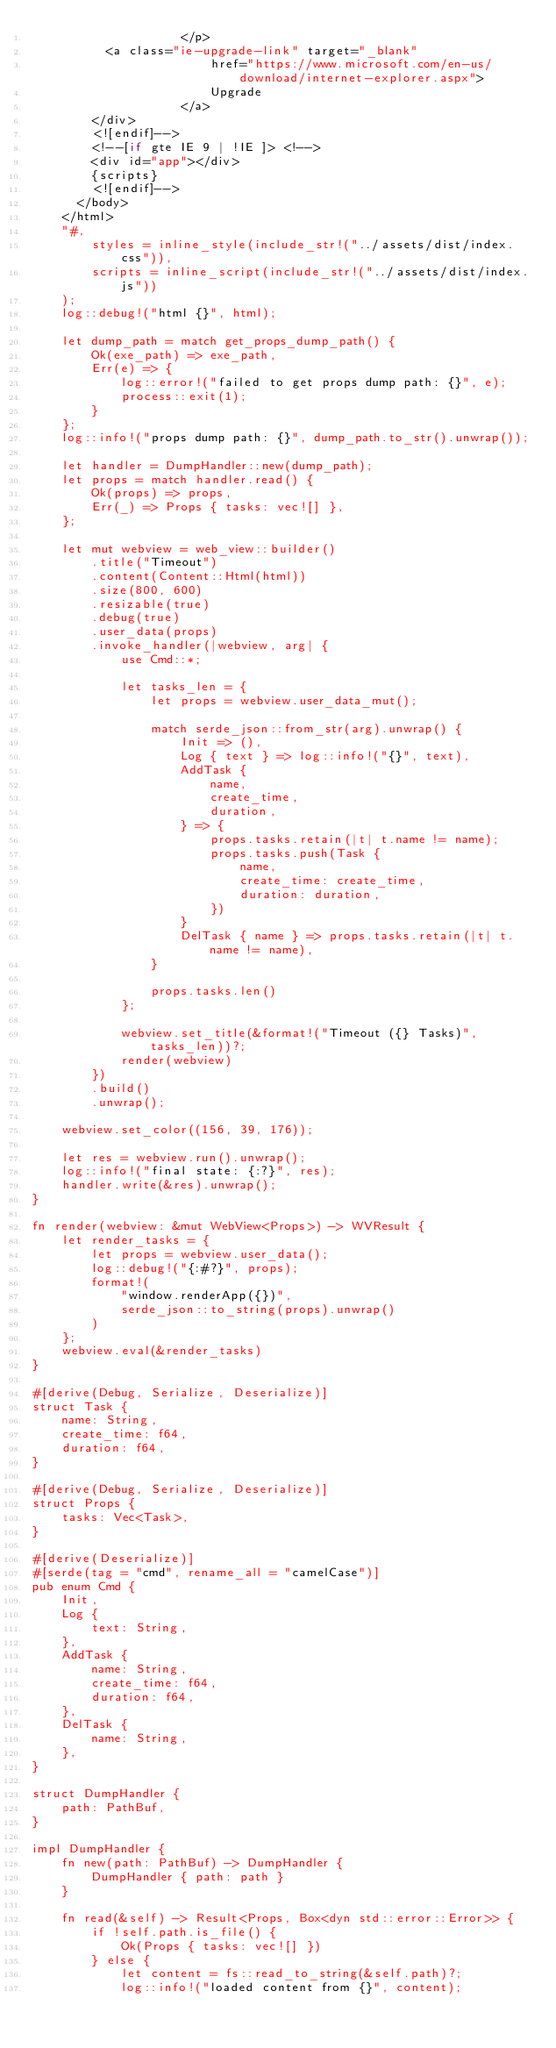<code> <loc_0><loc_0><loc_500><loc_500><_Rust_>                    </p>
					<a class="ie-upgrade-link" target="_blank"
                        href="https://www.microsoft.com/en-us/download/internet-explorer.aspx">
                        Upgrade
                    </a>
				</div>
				<![endif]-->
				<!--[if gte IE 9 | !IE ]> <!-->
				<div id="app"></div>
				{scripts}
				<![endif]-->
			</body>
		</html>
		"#,
        styles = inline_style(include_str!("../assets/dist/index.css")),
        scripts = inline_script(include_str!("../assets/dist/index.js"))
    );
    log::debug!("html {}", html);

    let dump_path = match get_props_dump_path() {
        Ok(exe_path) => exe_path,
        Err(e) => {
            log::error!("failed to get props dump path: {}", e);
            process::exit(1);
        }
    };
    log::info!("props dump path: {}", dump_path.to_str().unwrap());

    let handler = DumpHandler::new(dump_path);
    let props = match handler.read() {
        Ok(props) => props,
        Err(_) => Props { tasks: vec![] },
    };

    let mut webview = web_view::builder()
        .title("Timeout")
        .content(Content::Html(html))
        .size(800, 600)
        .resizable(true)
        .debug(true)
        .user_data(props)
        .invoke_handler(|webview, arg| {
            use Cmd::*;

            let tasks_len = {
                let props = webview.user_data_mut();

                match serde_json::from_str(arg).unwrap() {
                    Init => (),
                    Log { text } => log::info!("{}", text),
                    AddTask {
                        name,
                        create_time,
                        duration,
                    } => {
                        props.tasks.retain(|t| t.name != name);
                        props.tasks.push(Task {
                            name,
                            create_time: create_time,
                            duration: duration,
                        })
                    }
                    DelTask { name } => props.tasks.retain(|t| t.name != name),
                }

                props.tasks.len()
            };

            webview.set_title(&format!("Timeout ({} Tasks)", tasks_len))?;
            render(webview)
        })
        .build()
        .unwrap();

    webview.set_color((156, 39, 176));

    let res = webview.run().unwrap();
    log::info!("final state: {:?}", res);
    handler.write(&res).unwrap();
}

fn render(webview: &mut WebView<Props>) -> WVResult {
    let render_tasks = {
        let props = webview.user_data();
        log::debug!("{:#?}", props);
        format!(
            "window.renderApp({})",
            serde_json::to_string(props).unwrap()
        )
    };
    webview.eval(&render_tasks)
}

#[derive(Debug, Serialize, Deserialize)]
struct Task {
    name: String,
    create_time: f64,
    duration: f64,
}

#[derive(Debug, Serialize, Deserialize)]
struct Props {
    tasks: Vec<Task>,
}

#[derive(Deserialize)]
#[serde(tag = "cmd", rename_all = "camelCase")]
pub enum Cmd {
    Init,
    Log {
        text: String,
    },
    AddTask {
        name: String,
        create_time: f64,
        duration: f64,
    },
    DelTask {
        name: String,
    },
}

struct DumpHandler {
    path: PathBuf,
}

impl DumpHandler {
    fn new(path: PathBuf) -> DumpHandler {
        DumpHandler { path: path }
    }

    fn read(&self) -> Result<Props, Box<dyn std::error::Error>> {
        if !self.path.is_file() {
            Ok(Props { tasks: vec![] })
        } else {
            let content = fs::read_to_string(&self.path)?;
            log::info!("loaded content from {}", content);</code> 